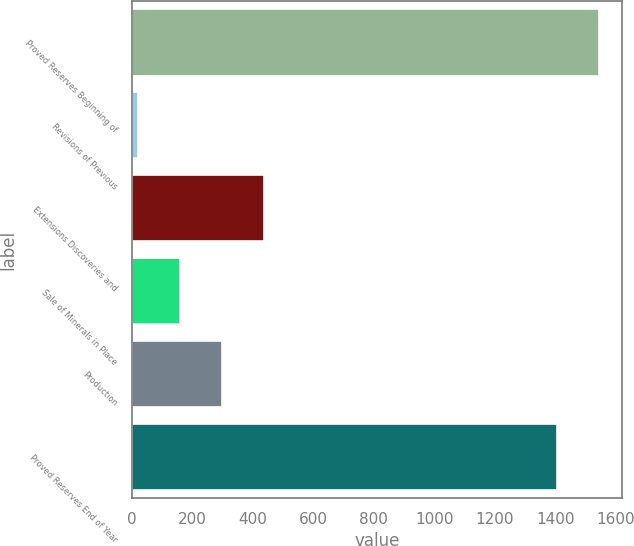<chart> <loc_0><loc_0><loc_500><loc_500><bar_chart><fcel>Proved Reserves Beginning of<fcel>Revisions of Previous<fcel>Extensions Discoveries and<fcel>Sale of Minerals in Place<fcel>Production<fcel>Proved Reserves End of Year<nl><fcel>1542.5<fcel>21<fcel>436.5<fcel>159.5<fcel>298<fcel>1404<nl></chart> 